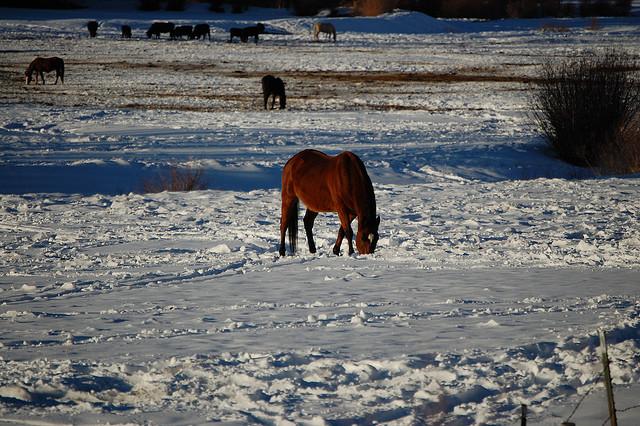Is this horse trying to eat snow?
Short answer required. No. Are the animals in the back fighting?
Quick response, please. No. Is it currently snowing?
Give a very brief answer. No. 